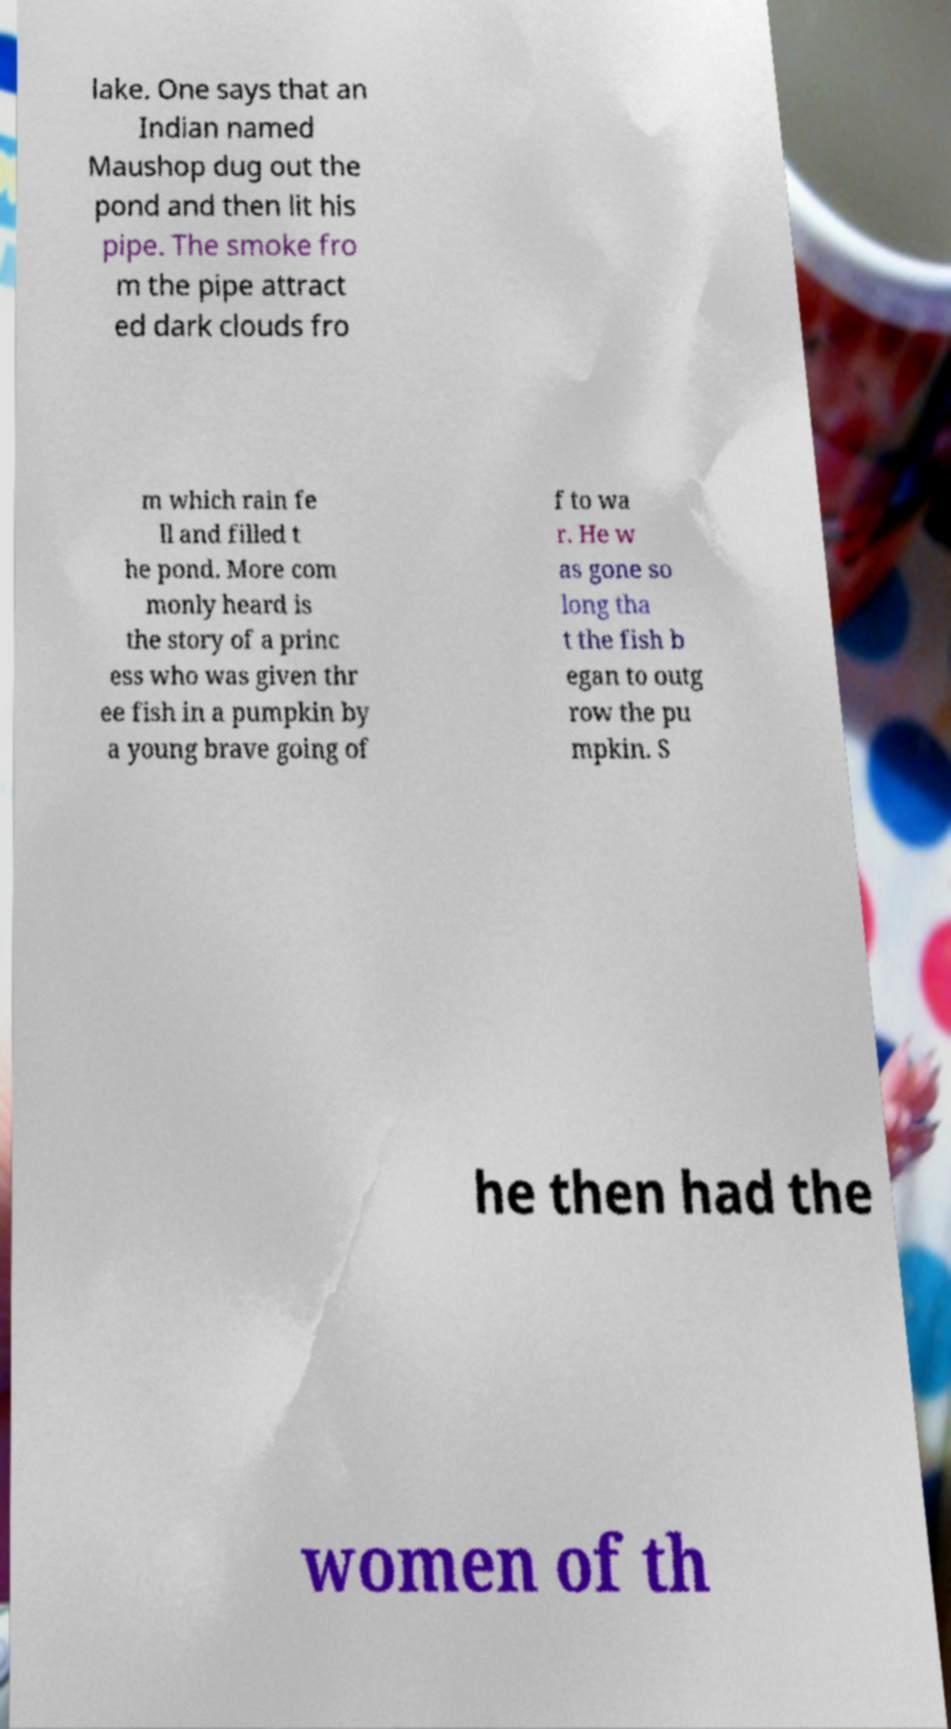What messages or text are displayed in this image? I need them in a readable, typed format. lake. One says that an Indian named Maushop dug out the pond and then lit his pipe. The smoke fro m the pipe attract ed dark clouds fro m which rain fe ll and filled t he pond. More com monly heard is the story of a princ ess who was given thr ee fish in a pumpkin by a young brave going of f to wa r. He w as gone so long tha t the fish b egan to outg row the pu mpkin. S he then had the women of th 